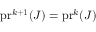<formula> <loc_0><loc_0><loc_500><loc_500>p r ^ { k + 1 } ( J ) = p r ^ { k } ( J )</formula> 